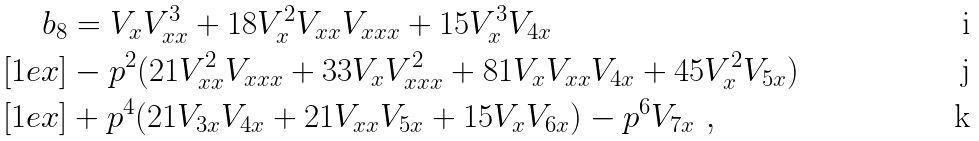<formula> <loc_0><loc_0><loc_500><loc_500>b _ { 8 } & = V _ { x } V _ { x x } ^ { 3 } + 1 8 V _ { x } ^ { 2 } V _ { x x } V _ { x x x } + 1 5 V _ { x } ^ { 3 } V _ { 4 x } \\ [ 1 e x ] & - p ^ { 2 } ( 2 1 V _ { x x } ^ { 2 } V _ { x x x } + 3 3 V _ { x } V _ { x x x } ^ { 2 } + 8 1 V _ { x } V _ { x x } V _ { 4 x } + 4 5 V _ { x } ^ { 2 } V _ { 5 x } ) \\ [ 1 e x ] & + p ^ { 4 } ( 2 1 V _ { 3 x } V _ { 4 x } + 2 1 V _ { x x } V _ { 5 x } + 1 5 V _ { x } V _ { 6 x } ) - p ^ { 6 } V _ { 7 x } \ ,</formula> 